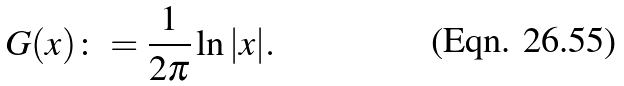Convert formula to latex. <formula><loc_0><loc_0><loc_500><loc_500>G ( x ) \colon = \frac { 1 } { 2 \pi } \ln | x | .</formula> 